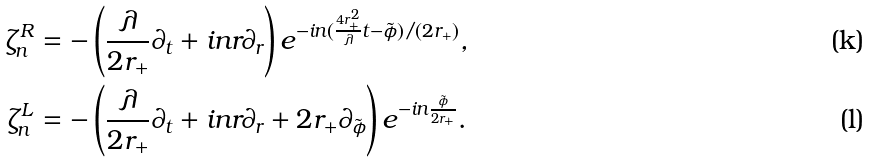<formula> <loc_0><loc_0><loc_500><loc_500>\zeta ^ { R } _ { n } & = - \left ( \frac { \lambda } { 2 r _ { + } } \partial _ { t } + i n r \partial _ { r } \right ) e ^ { - i n ( \frac { 4 r _ { + } ^ { 2 } } { \lambda } t - \tilde { \phi } ) / ( 2 r _ { + } ) } , \\ \zeta ^ { L } _ { n } & = - \left ( \frac { \lambda } { 2 r _ { + } } \partial _ { t } + i n r \partial _ { r } + 2 r _ { + } \partial _ { \tilde { \phi } } \right ) e ^ { - i n \frac { \tilde { \phi } } { 2 r _ { + } } } .</formula> 